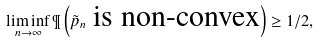<formula> <loc_0><loc_0><loc_500><loc_500>\liminf _ { n \to \infty } \P \left ( \tilde { p } _ { n } \text { is non-convex} \right ) \geq 1 / 2 ,</formula> 